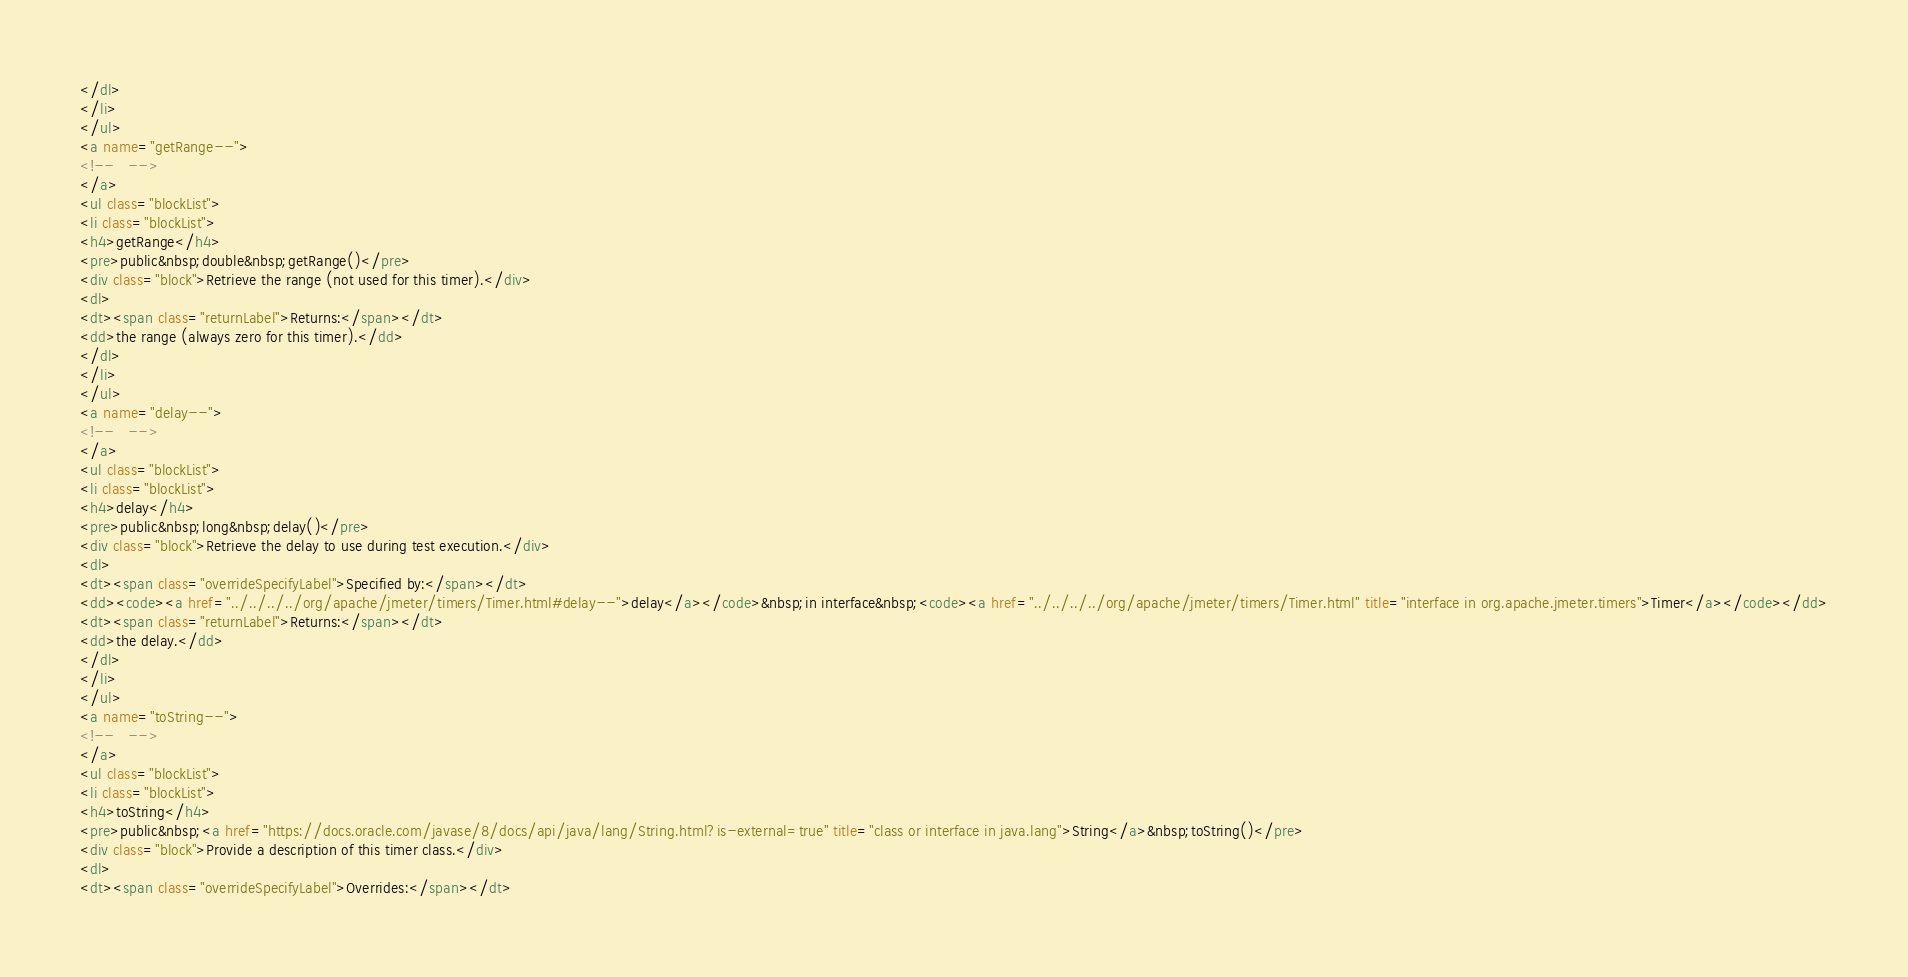Convert code to text. <code><loc_0><loc_0><loc_500><loc_500><_HTML_></dl>
</li>
</ul>
<a name="getRange--">
<!--   -->
</a>
<ul class="blockList">
<li class="blockList">
<h4>getRange</h4>
<pre>public&nbsp;double&nbsp;getRange()</pre>
<div class="block">Retrieve the range (not used for this timer).</div>
<dl>
<dt><span class="returnLabel">Returns:</span></dt>
<dd>the range (always zero for this timer).</dd>
</dl>
</li>
</ul>
<a name="delay--">
<!--   -->
</a>
<ul class="blockList">
<li class="blockList">
<h4>delay</h4>
<pre>public&nbsp;long&nbsp;delay()</pre>
<div class="block">Retrieve the delay to use during test execution.</div>
<dl>
<dt><span class="overrideSpecifyLabel">Specified by:</span></dt>
<dd><code><a href="../../../../org/apache/jmeter/timers/Timer.html#delay--">delay</a></code>&nbsp;in interface&nbsp;<code><a href="../../../../org/apache/jmeter/timers/Timer.html" title="interface in org.apache.jmeter.timers">Timer</a></code></dd>
<dt><span class="returnLabel">Returns:</span></dt>
<dd>the delay.</dd>
</dl>
</li>
</ul>
<a name="toString--">
<!--   -->
</a>
<ul class="blockList">
<li class="blockList">
<h4>toString</h4>
<pre>public&nbsp;<a href="https://docs.oracle.com/javase/8/docs/api/java/lang/String.html?is-external=true" title="class or interface in java.lang">String</a>&nbsp;toString()</pre>
<div class="block">Provide a description of this timer class.</div>
<dl>
<dt><span class="overrideSpecifyLabel">Overrides:</span></dt></code> 